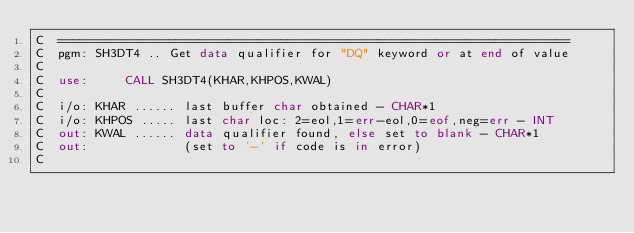Convert code to text. <code><loc_0><loc_0><loc_500><loc_500><_FORTRAN_>C  =====================================================================
C  pgm: SH3DT4 .. Get data qualifier for "DQ" keyword or at end of value
C
C  use:     CALL SH3DT4(KHAR,KHPOS,KWAL)
C
C  i/o: KHAR ...... last buffer char obtained - CHAR*1
C  i/o: KHPOS ..... last char loc: 2=eol,1=err-eol,0=eof,neg=err - INT
C  out: KWAL ...... data qualifier found, else set to blank - CHAR*1
C  out:             (set to '-' if code is in error)
C</code> 